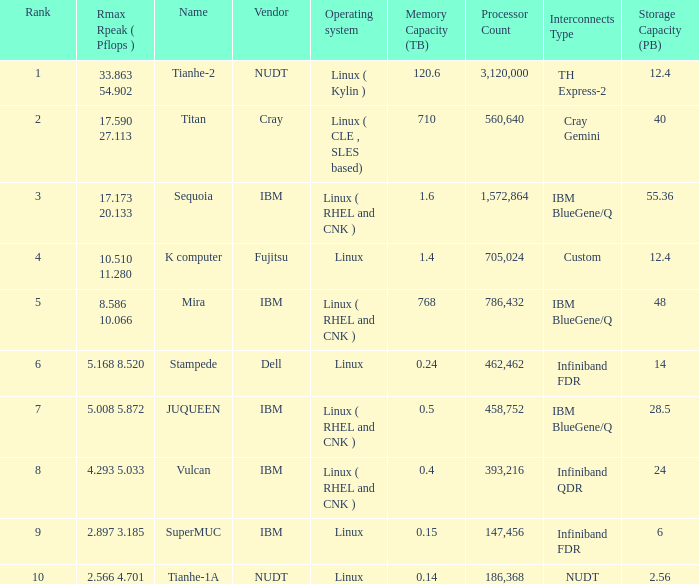What is the rank of Rmax Rpeak ( Pflops ) of 17.173 20.133? 3.0. Write the full table. {'header': ['Rank', 'Rmax Rpeak ( Pflops )', 'Name', 'Vendor', 'Operating system', 'Memory Capacity (TB)', 'Processor Count', 'Interconnects Type', 'Storage Capacity (PB)'], 'rows': [['1', '33.863 54.902', 'Tianhe-2', 'NUDT', 'Linux ( Kylin )', '120.6', '3,120,000', 'TH Express-2', '12.4'], ['2', '17.590 27.113', 'Titan', 'Cray', 'Linux ( CLE , SLES based)', '710', '560,640', 'Cray Gemini', '40'], ['3', '17.173 20.133', 'Sequoia', 'IBM', 'Linux ( RHEL and CNK )', '1.6', '1,572,864', 'IBM BlueGene/Q', '55.36'], ['4', '10.510 11.280', 'K computer', 'Fujitsu', 'Linux', '1.4', '705,024', 'Custom', '12.4'], ['5', '8.586 10.066', 'Mira', 'IBM', 'Linux ( RHEL and CNK )', '768', '786,432', 'IBM BlueGene/Q', '48'], ['6', '5.168 8.520', 'Stampede', 'Dell', 'Linux', '0.24', '462,462', 'Infiniband FDR', '14'], ['7', '5.008 5.872', 'JUQUEEN', 'IBM', 'Linux ( RHEL and CNK )', '0.5', '458,752', 'IBM BlueGene/Q', '28.5'], ['8', '4.293 5.033', 'Vulcan', 'IBM', 'Linux ( RHEL and CNK )', '0.4', '393,216', 'Infiniband QDR', '24'], ['9', '2.897 3.185', 'SuperMUC', 'IBM', 'Linux', '0.15', '147,456', 'Infiniband FDR', '6'], ['10', '2.566 4.701', 'Tianhe-1A', 'NUDT', 'Linux', '0.14', '186,368', 'NUDT', '2.56']]} 